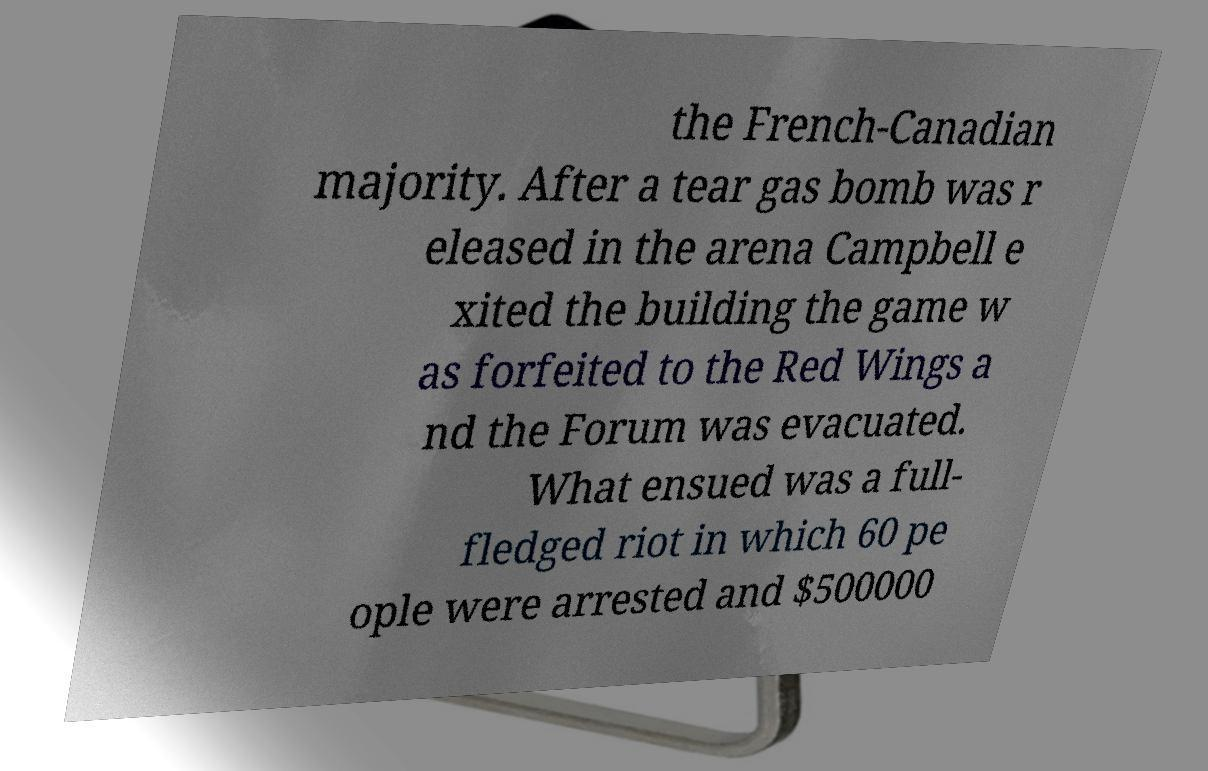For documentation purposes, I need the text within this image transcribed. Could you provide that? the French-Canadian majority. After a tear gas bomb was r eleased in the arena Campbell e xited the building the game w as forfeited to the Red Wings a nd the Forum was evacuated. What ensued was a full- fledged riot in which 60 pe ople were arrested and $500000 